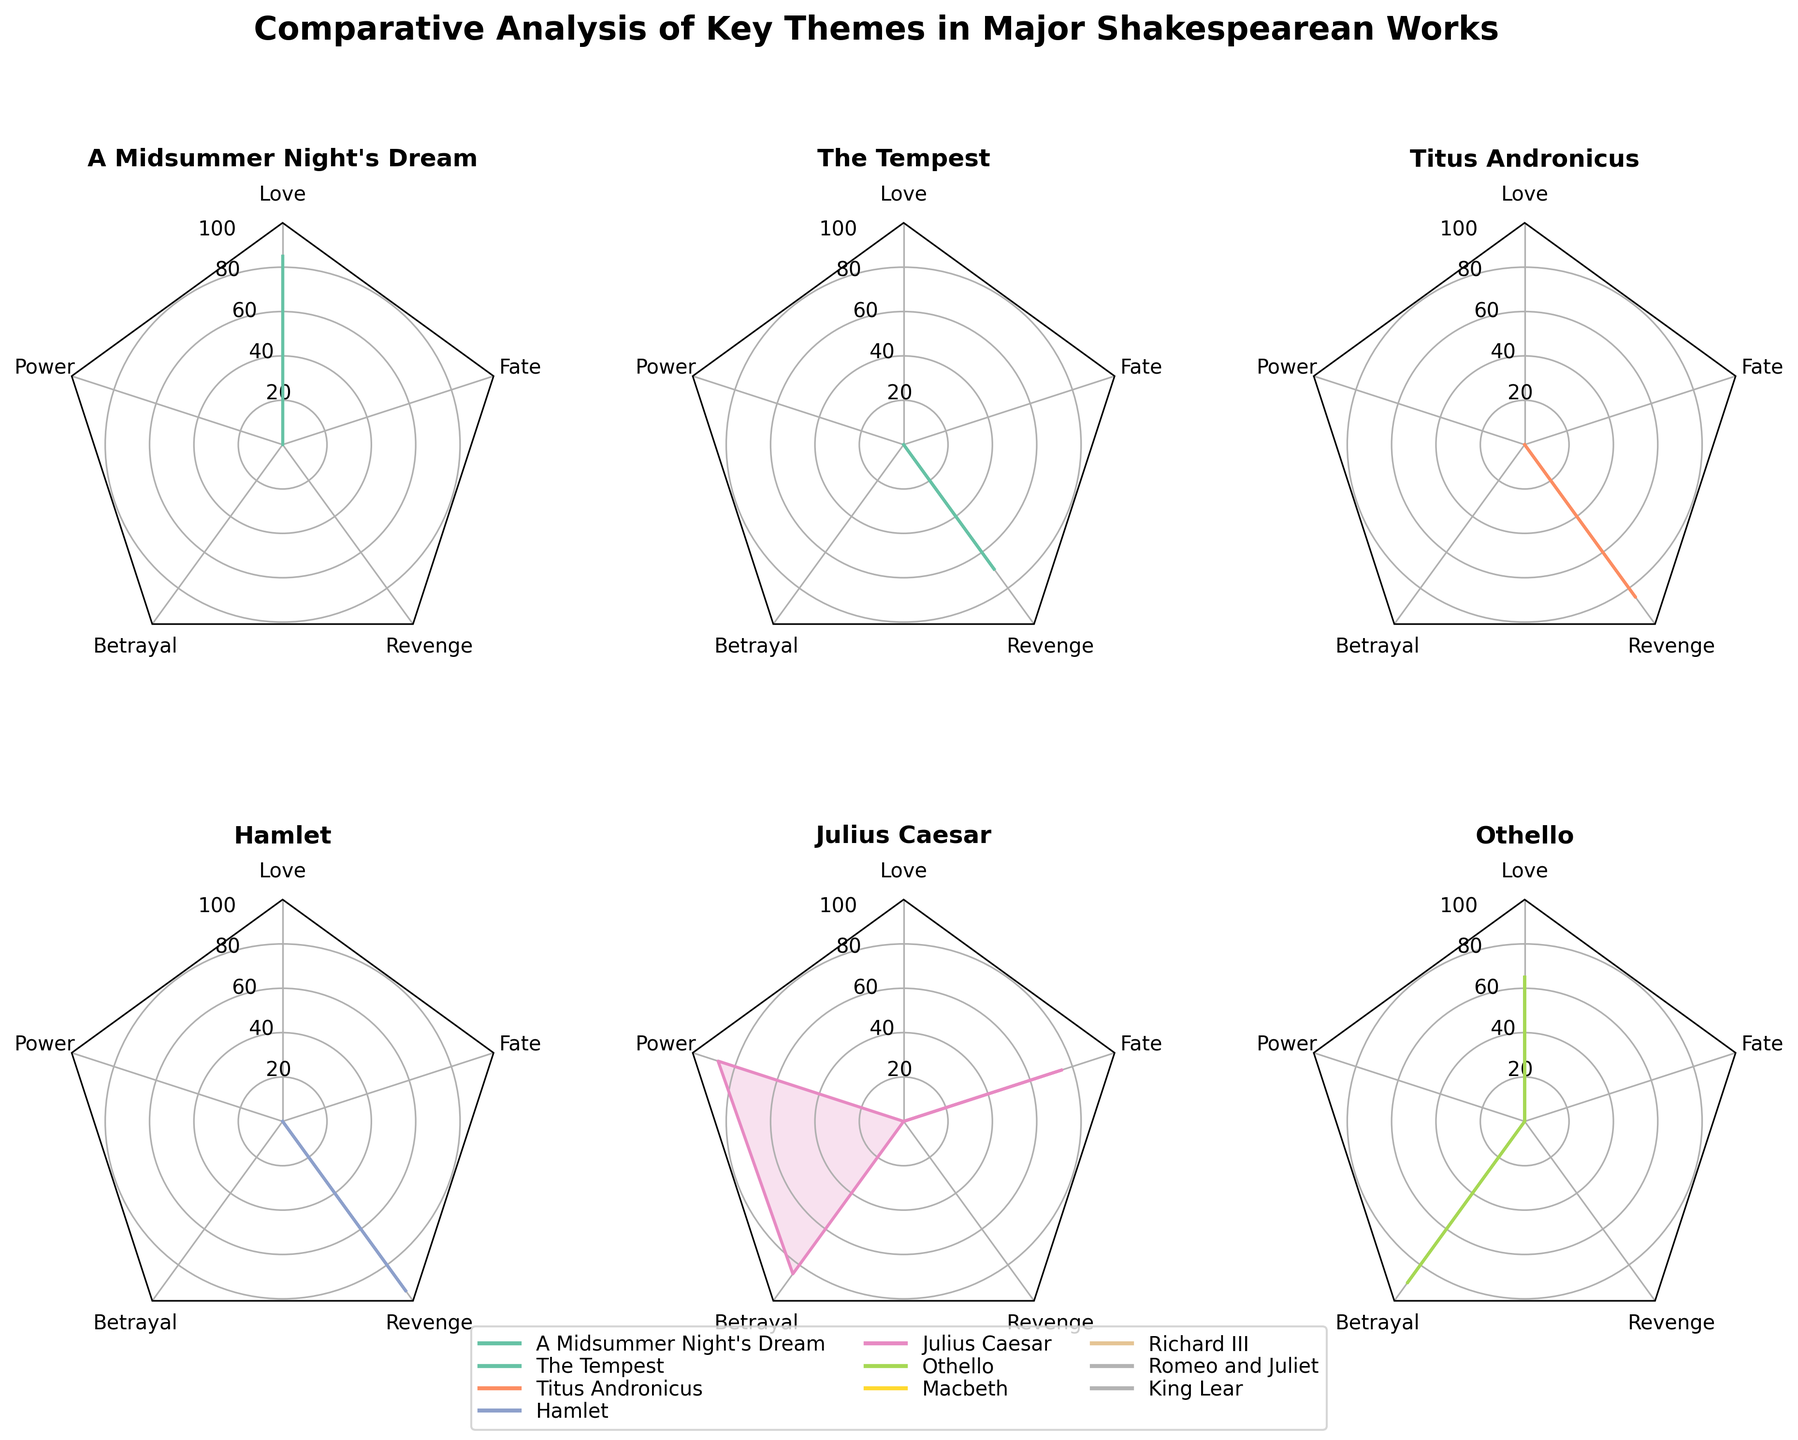Which work depicts the theme of Love the most prominently? By looking at the subplot for the Love theme, we observe the value for each work. "Romeo and Juliet" has a value of 95, which is the highest among the listed works.
Answer: Romeo and Juliet What are the works analyzed for the theme of Betrayal? Checking the subplot for Betrayal, we see the works: "Othello," "Julius Caesar," and "King Lear."
Answer: Othello, Julius Caesar, King Lear Which theme shows maximum prominence in "Hamlet"? In the subplot for "Hamlet," the value for the theme of Revenge is 95, which is the highest value for themes depicted in "Hamlet."
Answer: Revenge Compare the presentation of Power in "Macbeth" and "Julius Caesar." By looking at the subplots, the values for Power are 90 in "Macbeth" and 88 in "Julius Caesar." Hence, "Macbeth" shows a slightly higher prominence of the Power theme.
Answer: "Macbeth" has a higher prominence of the Power theme What is the average value of the theme Betrayal across "Othello," "Julius Caesar," and "King Lear"? To find the average, sum the values of Betrayal for the three works: 90 (Othello) + 85 (Julius Caesar) + 88 (King Lear) = 263. Then divide by 3. 263/3 = 87.67.
Answer: 87.67 Which work has the least representation in the theme of Revenge? By examining the subplots for Revenge, "The Tempest" has a value of 70, which is the lowest among the given works.
Answer: The Tempest How does the theme of Fate vary across "Romeo and Juliet," "Macbeth," and "Julius Caesar"? Checking the subplot for Fate, we observe the values: "Romeo and Juliet" - 80, "Macbeth" - 85, and "Julius Caesar" - 75. Hence, "Macbeth" has the highest value, followed by "Romeo and Juliet," and "Julius Caesar" has the lowest.
Answer: Macbeth > Romeo and Juliet > Julius Caesar Identify the theme that is equally represented in "Macbeth" and "Julius Caesar." By comparing each theme in both subplots, we see that the value for the theme of Fate is equal in "Macbeth" (85) and "Julius Caesar" (85).
Answer: Fate Compare the themes of Love and Betrayal in "Othello." Which is more prominent? In the subplot for "Othello," the values for the themes of Love and Betrayal are 65 and 90, respectively. Hence, Betrayal is more prominent.
Answer: Betrayal 